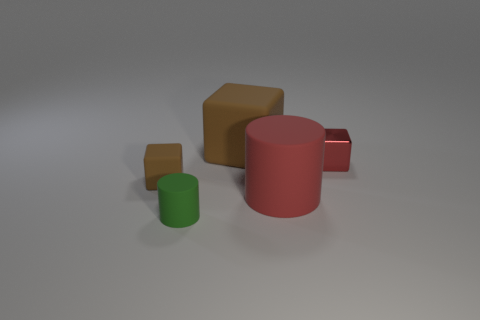How many objects are there and what are their shapes? There are four objects in the image, consisting of two cylinders and two cubes. The cubes are characterized by their angular, six-sided structure and the cylinders by their round, tubular shape. 